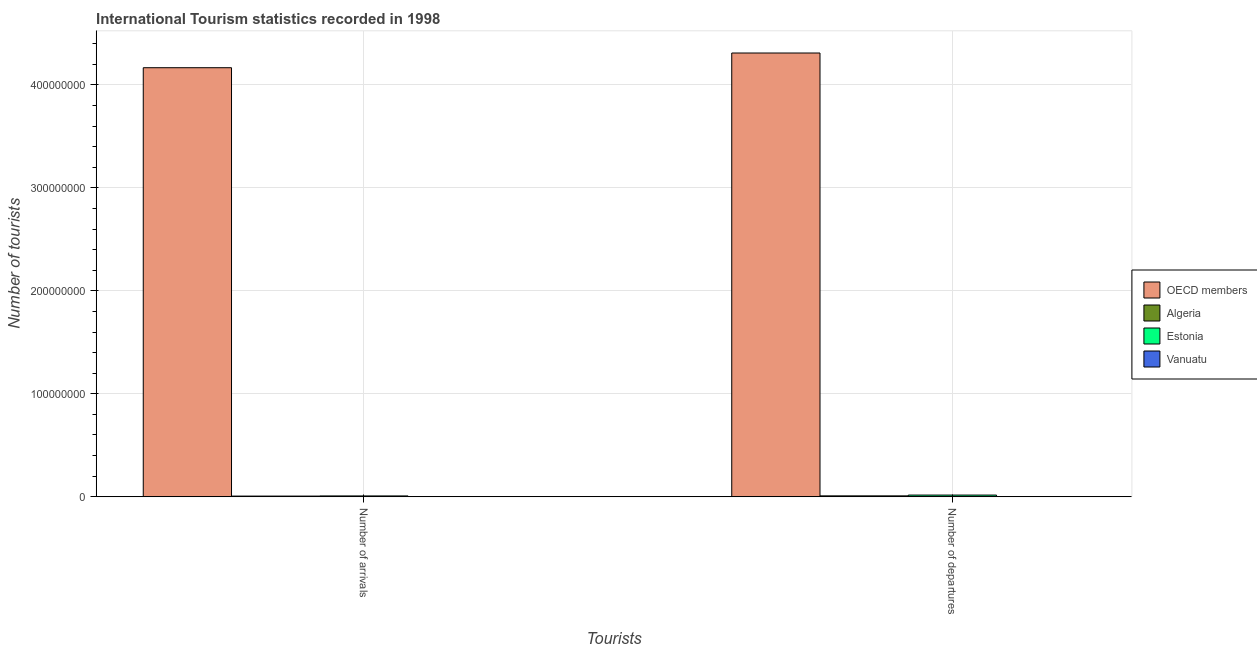How many different coloured bars are there?
Your answer should be compact. 4. Are the number of bars per tick equal to the number of legend labels?
Offer a terse response. Yes. How many bars are there on the 1st tick from the right?
Your answer should be compact. 4. What is the label of the 2nd group of bars from the left?
Provide a succinct answer. Number of departures. What is the number of tourist departures in OECD members?
Give a very brief answer. 4.31e+08. Across all countries, what is the maximum number of tourist departures?
Offer a terse response. 4.31e+08. Across all countries, what is the minimum number of tourist arrivals?
Your answer should be very brief. 5.20e+04. In which country was the number of tourist arrivals maximum?
Provide a short and direct response. OECD members. In which country was the number of tourist arrivals minimum?
Keep it short and to the point. Vanuatu. What is the total number of tourist departures in the graph?
Give a very brief answer. 4.33e+08. What is the difference between the number of tourist departures in OECD members and that in Estonia?
Your response must be concise. 4.29e+08. What is the difference between the number of tourist departures in Algeria and the number of tourist arrivals in OECD members?
Ensure brevity in your answer.  -4.16e+08. What is the average number of tourist arrivals per country?
Ensure brevity in your answer.  1.05e+08. What is the difference between the number of tourist arrivals and number of tourist departures in Vanuatu?
Keep it short and to the point. 4.00e+04. In how many countries, is the number of tourist arrivals greater than 140000000 ?
Ensure brevity in your answer.  1. What is the ratio of the number of tourist departures in Algeria to that in Vanuatu?
Keep it short and to the point. 73.25. Is the number of tourist arrivals in Estonia less than that in Algeria?
Give a very brief answer. No. In how many countries, is the number of tourist arrivals greater than the average number of tourist arrivals taken over all countries?
Your response must be concise. 1. What does the 3rd bar from the left in Number of arrivals represents?
Offer a very short reply. Estonia. What does the 1st bar from the right in Number of arrivals represents?
Offer a terse response. Vanuatu. What is the difference between two consecutive major ticks on the Y-axis?
Ensure brevity in your answer.  1.00e+08. Does the graph contain grids?
Your answer should be very brief. Yes. Where does the legend appear in the graph?
Your answer should be compact. Center right. How many legend labels are there?
Your answer should be compact. 4. How are the legend labels stacked?
Make the answer very short. Vertical. What is the title of the graph?
Offer a very short reply. International Tourism statistics recorded in 1998. Does "Isle of Man" appear as one of the legend labels in the graph?
Offer a very short reply. No. What is the label or title of the X-axis?
Your answer should be very brief. Tourists. What is the label or title of the Y-axis?
Offer a very short reply. Number of tourists. What is the Number of tourists of OECD members in Number of arrivals?
Provide a short and direct response. 4.17e+08. What is the Number of tourists of Algeria in Number of arrivals?
Keep it short and to the point. 6.78e+05. What is the Number of tourists of Estonia in Number of arrivals?
Provide a short and direct response. 8.25e+05. What is the Number of tourists in Vanuatu in Number of arrivals?
Keep it short and to the point. 5.20e+04. What is the Number of tourists in OECD members in Number of departures?
Keep it short and to the point. 4.31e+08. What is the Number of tourists of Algeria in Number of departures?
Your answer should be compact. 8.79e+05. What is the Number of tourists in Estonia in Number of departures?
Offer a terse response. 1.66e+06. What is the Number of tourists in Vanuatu in Number of departures?
Your answer should be compact. 1.20e+04. Across all Tourists, what is the maximum Number of tourists in OECD members?
Ensure brevity in your answer.  4.31e+08. Across all Tourists, what is the maximum Number of tourists in Algeria?
Give a very brief answer. 8.79e+05. Across all Tourists, what is the maximum Number of tourists of Estonia?
Give a very brief answer. 1.66e+06. Across all Tourists, what is the maximum Number of tourists in Vanuatu?
Your answer should be very brief. 5.20e+04. Across all Tourists, what is the minimum Number of tourists in OECD members?
Offer a terse response. 4.17e+08. Across all Tourists, what is the minimum Number of tourists in Algeria?
Provide a succinct answer. 6.78e+05. Across all Tourists, what is the minimum Number of tourists in Estonia?
Make the answer very short. 8.25e+05. Across all Tourists, what is the minimum Number of tourists of Vanuatu?
Your answer should be compact. 1.20e+04. What is the total Number of tourists in OECD members in the graph?
Offer a very short reply. 8.48e+08. What is the total Number of tourists in Algeria in the graph?
Offer a terse response. 1.56e+06. What is the total Number of tourists of Estonia in the graph?
Give a very brief answer. 2.48e+06. What is the total Number of tourists of Vanuatu in the graph?
Ensure brevity in your answer.  6.40e+04. What is the difference between the Number of tourists of OECD members in Number of arrivals and that in Number of departures?
Your answer should be very brief. -1.43e+07. What is the difference between the Number of tourists in Algeria in Number of arrivals and that in Number of departures?
Ensure brevity in your answer.  -2.01e+05. What is the difference between the Number of tourists of Estonia in Number of arrivals and that in Number of departures?
Keep it short and to the point. -8.34e+05. What is the difference between the Number of tourists in Vanuatu in Number of arrivals and that in Number of departures?
Offer a very short reply. 4.00e+04. What is the difference between the Number of tourists in OECD members in Number of arrivals and the Number of tourists in Algeria in Number of departures?
Provide a short and direct response. 4.16e+08. What is the difference between the Number of tourists in OECD members in Number of arrivals and the Number of tourists in Estonia in Number of departures?
Keep it short and to the point. 4.15e+08. What is the difference between the Number of tourists in OECD members in Number of arrivals and the Number of tourists in Vanuatu in Number of departures?
Offer a terse response. 4.17e+08. What is the difference between the Number of tourists in Algeria in Number of arrivals and the Number of tourists in Estonia in Number of departures?
Give a very brief answer. -9.81e+05. What is the difference between the Number of tourists in Algeria in Number of arrivals and the Number of tourists in Vanuatu in Number of departures?
Provide a succinct answer. 6.66e+05. What is the difference between the Number of tourists in Estonia in Number of arrivals and the Number of tourists in Vanuatu in Number of departures?
Provide a short and direct response. 8.13e+05. What is the average Number of tourists of OECD members per Tourists?
Offer a terse response. 4.24e+08. What is the average Number of tourists in Algeria per Tourists?
Your response must be concise. 7.78e+05. What is the average Number of tourists of Estonia per Tourists?
Offer a terse response. 1.24e+06. What is the average Number of tourists in Vanuatu per Tourists?
Your answer should be very brief. 3.20e+04. What is the difference between the Number of tourists in OECD members and Number of tourists in Algeria in Number of arrivals?
Keep it short and to the point. 4.16e+08. What is the difference between the Number of tourists of OECD members and Number of tourists of Estonia in Number of arrivals?
Keep it short and to the point. 4.16e+08. What is the difference between the Number of tourists of OECD members and Number of tourists of Vanuatu in Number of arrivals?
Offer a very short reply. 4.17e+08. What is the difference between the Number of tourists of Algeria and Number of tourists of Estonia in Number of arrivals?
Your answer should be compact. -1.47e+05. What is the difference between the Number of tourists in Algeria and Number of tourists in Vanuatu in Number of arrivals?
Provide a succinct answer. 6.26e+05. What is the difference between the Number of tourists of Estonia and Number of tourists of Vanuatu in Number of arrivals?
Provide a short and direct response. 7.73e+05. What is the difference between the Number of tourists in OECD members and Number of tourists in Algeria in Number of departures?
Your answer should be very brief. 4.30e+08. What is the difference between the Number of tourists of OECD members and Number of tourists of Estonia in Number of departures?
Provide a succinct answer. 4.29e+08. What is the difference between the Number of tourists of OECD members and Number of tourists of Vanuatu in Number of departures?
Make the answer very short. 4.31e+08. What is the difference between the Number of tourists in Algeria and Number of tourists in Estonia in Number of departures?
Make the answer very short. -7.80e+05. What is the difference between the Number of tourists in Algeria and Number of tourists in Vanuatu in Number of departures?
Offer a very short reply. 8.67e+05. What is the difference between the Number of tourists in Estonia and Number of tourists in Vanuatu in Number of departures?
Provide a short and direct response. 1.65e+06. What is the ratio of the Number of tourists in OECD members in Number of arrivals to that in Number of departures?
Make the answer very short. 0.97. What is the ratio of the Number of tourists in Algeria in Number of arrivals to that in Number of departures?
Give a very brief answer. 0.77. What is the ratio of the Number of tourists of Estonia in Number of arrivals to that in Number of departures?
Offer a very short reply. 0.5. What is the ratio of the Number of tourists in Vanuatu in Number of arrivals to that in Number of departures?
Ensure brevity in your answer.  4.33. What is the difference between the highest and the second highest Number of tourists in OECD members?
Your response must be concise. 1.43e+07. What is the difference between the highest and the second highest Number of tourists of Algeria?
Give a very brief answer. 2.01e+05. What is the difference between the highest and the second highest Number of tourists in Estonia?
Provide a succinct answer. 8.34e+05. What is the difference between the highest and the second highest Number of tourists in Vanuatu?
Give a very brief answer. 4.00e+04. What is the difference between the highest and the lowest Number of tourists of OECD members?
Your answer should be compact. 1.43e+07. What is the difference between the highest and the lowest Number of tourists in Algeria?
Your response must be concise. 2.01e+05. What is the difference between the highest and the lowest Number of tourists in Estonia?
Provide a short and direct response. 8.34e+05. 